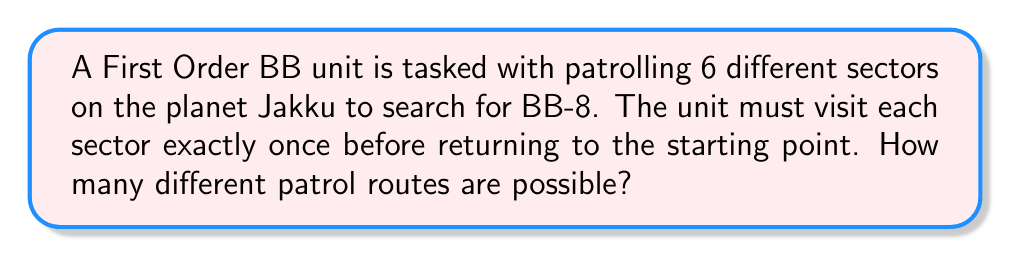Can you answer this question? Let's approach this step-by-step:

1) This problem is essentially asking for the number of circular permutations of 6 elements.

2) For circular permutations, we consider one position fixed (in this case, we can consider the starting point fixed) and then calculate the permutations of the remaining elements.

3) The formula for circular permutations of $n$ elements is $(n-1)!$

4) In this case, $n = 6$ (the number of sectors)

5) Therefore, we need to calculate $(6-1)! = 5!$

6) $5! = 5 \times 4 \times 3 \times 2 \times 1 = 120$

Thus, there are 120 possible patrol routes for the First Order BB unit to search for BB-8.
Answer: 120 